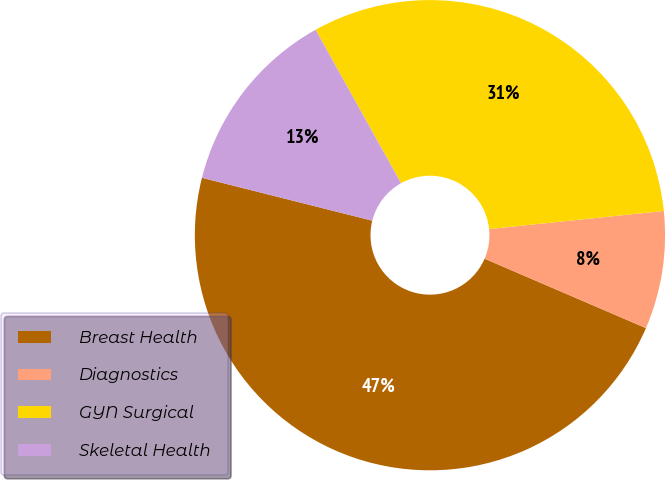Convert chart. <chart><loc_0><loc_0><loc_500><loc_500><pie_chart><fcel>Breast Health<fcel>Diagnostics<fcel>GYN Surgical<fcel>Skeletal Health<nl><fcel>47.46%<fcel>8.11%<fcel>31.44%<fcel>12.99%<nl></chart> 